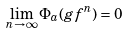Convert formula to latex. <formula><loc_0><loc_0><loc_500><loc_500>\lim _ { n \to \infty } \Phi _ { a } ( g f ^ { n } ) = 0</formula> 